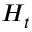Convert formula to latex. <formula><loc_0><loc_0><loc_500><loc_500>H _ { t }</formula> 